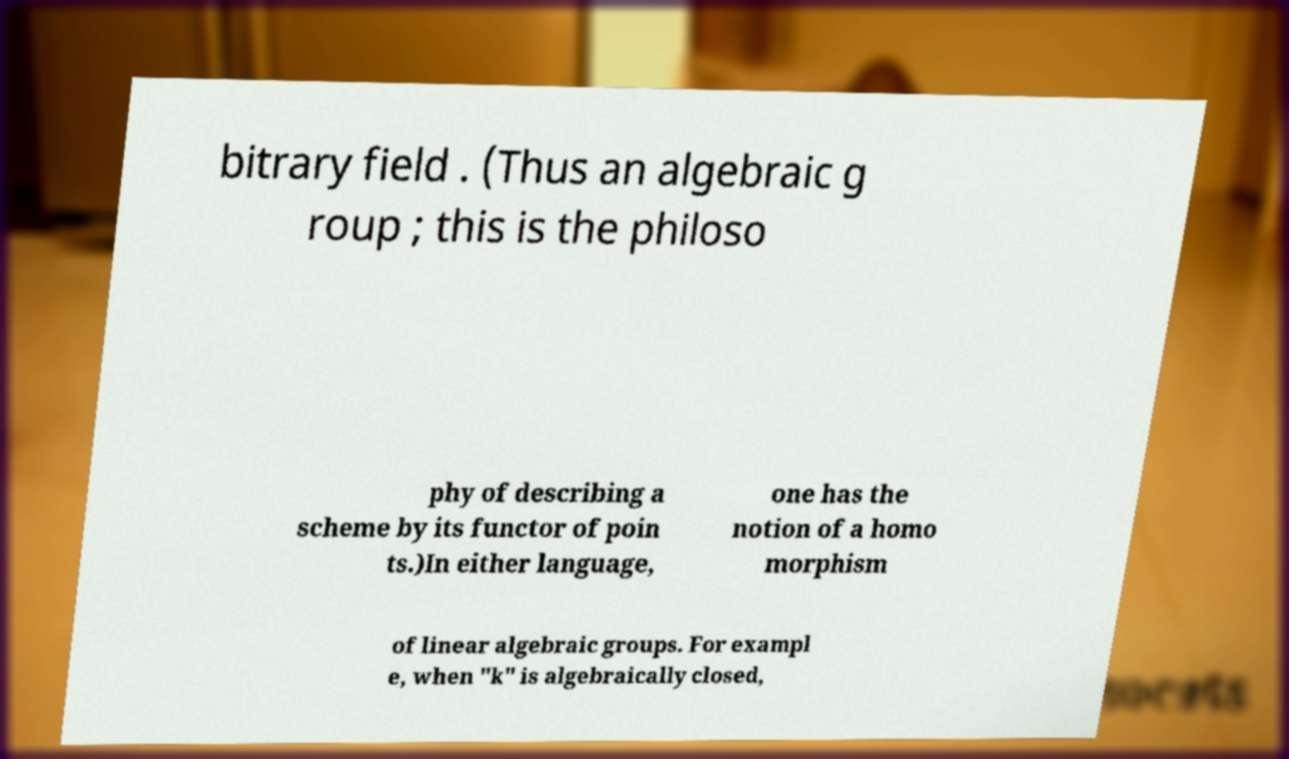Can you accurately transcribe the text from the provided image for me? bitrary field . (Thus an algebraic g roup ; this is the philoso phy of describing a scheme by its functor of poin ts.)In either language, one has the notion of a homo morphism of linear algebraic groups. For exampl e, when "k" is algebraically closed, 